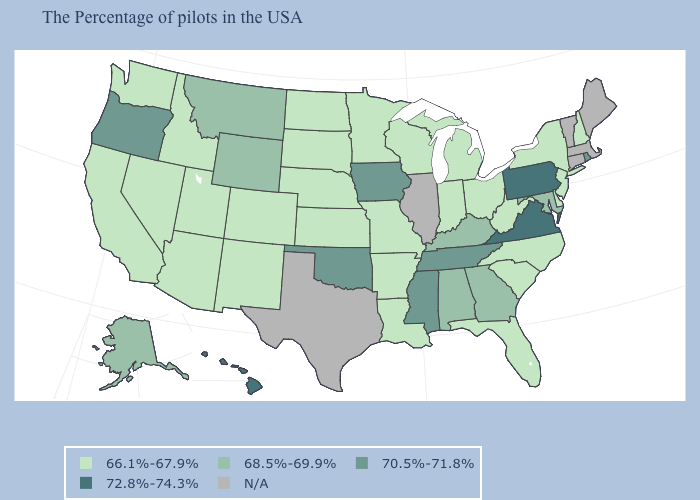What is the value of New Jersey?
Answer briefly. 66.1%-67.9%. Does California have the lowest value in the USA?
Keep it brief. Yes. Which states have the lowest value in the West?
Be succinct. Colorado, New Mexico, Utah, Arizona, Idaho, Nevada, California, Washington. Does New Mexico have the lowest value in the West?
Write a very short answer. Yes. What is the highest value in the USA?
Be succinct. 72.8%-74.3%. Which states have the lowest value in the Northeast?
Concise answer only. New Hampshire, New York, New Jersey. Does Iowa have the lowest value in the USA?
Answer briefly. No. Does the map have missing data?
Concise answer only. Yes. What is the value of Indiana?
Concise answer only. 66.1%-67.9%. What is the highest value in the USA?
Concise answer only. 72.8%-74.3%. Name the states that have a value in the range 68.5%-69.9%?
Answer briefly. Maryland, Georgia, Kentucky, Alabama, Wyoming, Montana, Alaska. What is the value of Illinois?
Concise answer only. N/A. What is the value of Maryland?
Short answer required. 68.5%-69.9%. What is the highest value in states that border New York?
Write a very short answer. 72.8%-74.3%. 